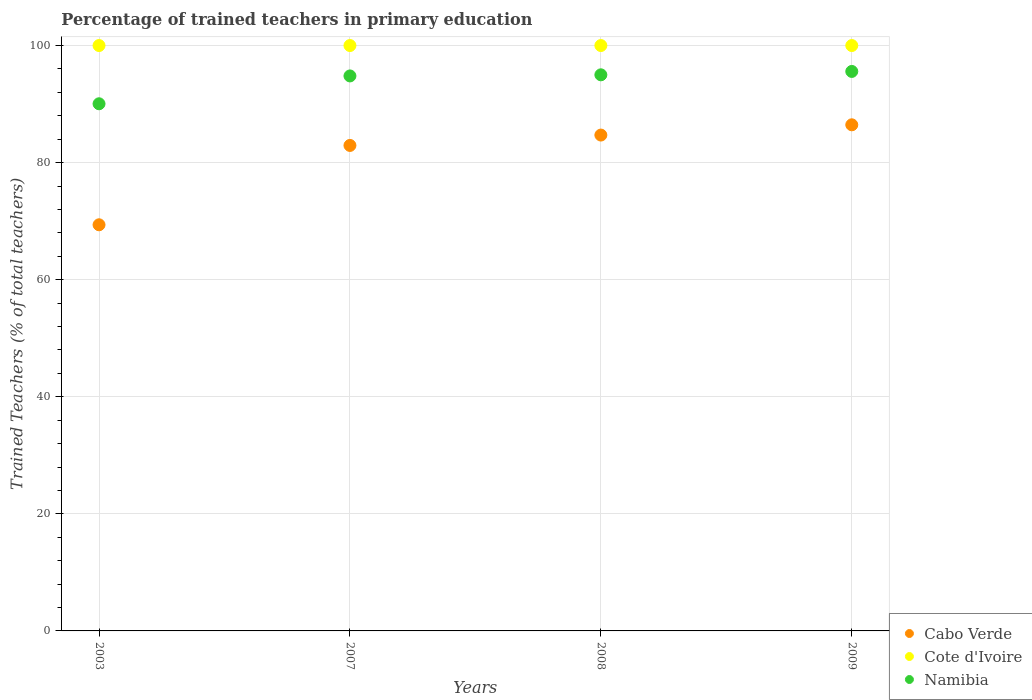What is the percentage of trained teachers in Namibia in 2009?
Ensure brevity in your answer.  95.58. Across all years, what is the maximum percentage of trained teachers in Namibia?
Make the answer very short. 95.58. Across all years, what is the minimum percentage of trained teachers in Cabo Verde?
Offer a very short reply. 69.38. In which year was the percentage of trained teachers in Cote d'Ivoire maximum?
Keep it short and to the point. 2003. In which year was the percentage of trained teachers in Cote d'Ivoire minimum?
Make the answer very short. 2003. What is the total percentage of trained teachers in Namibia in the graph?
Your answer should be compact. 375.43. What is the difference between the percentage of trained teachers in Cote d'Ivoire in 2008 and that in 2009?
Offer a terse response. 0. What is the difference between the percentage of trained teachers in Cabo Verde in 2008 and the percentage of trained teachers in Namibia in 2007?
Your answer should be compact. -10.1. In the year 2003, what is the difference between the percentage of trained teachers in Namibia and percentage of trained teachers in Cabo Verde?
Keep it short and to the point. 20.67. In how many years, is the percentage of trained teachers in Cabo Verde greater than 48 %?
Keep it short and to the point. 4. What is the ratio of the percentage of trained teachers in Cabo Verde in 2007 to that in 2008?
Offer a very short reply. 0.98. What is the difference between the highest and the second highest percentage of trained teachers in Cabo Verde?
Ensure brevity in your answer.  1.75. In how many years, is the percentage of trained teachers in Namibia greater than the average percentage of trained teachers in Namibia taken over all years?
Your answer should be very brief. 3. Is the percentage of trained teachers in Cote d'Ivoire strictly greater than the percentage of trained teachers in Cabo Verde over the years?
Keep it short and to the point. Yes. How many years are there in the graph?
Your answer should be very brief. 4. Does the graph contain any zero values?
Ensure brevity in your answer.  No. How are the legend labels stacked?
Your answer should be compact. Vertical. What is the title of the graph?
Offer a terse response. Percentage of trained teachers in primary education. Does "Other small states" appear as one of the legend labels in the graph?
Offer a terse response. No. What is the label or title of the X-axis?
Offer a very short reply. Years. What is the label or title of the Y-axis?
Your response must be concise. Trained Teachers (% of total teachers). What is the Trained Teachers (% of total teachers) in Cabo Verde in 2003?
Your answer should be compact. 69.38. What is the Trained Teachers (% of total teachers) in Cote d'Ivoire in 2003?
Ensure brevity in your answer.  100. What is the Trained Teachers (% of total teachers) in Namibia in 2003?
Your answer should be very brief. 90.05. What is the Trained Teachers (% of total teachers) of Cabo Verde in 2007?
Give a very brief answer. 82.93. What is the Trained Teachers (% of total teachers) of Cote d'Ivoire in 2007?
Provide a succinct answer. 100. What is the Trained Teachers (% of total teachers) in Namibia in 2007?
Your answer should be compact. 94.81. What is the Trained Teachers (% of total teachers) of Cabo Verde in 2008?
Offer a terse response. 84.71. What is the Trained Teachers (% of total teachers) in Namibia in 2008?
Give a very brief answer. 95. What is the Trained Teachers (% of total teachers) of Cabo Verde in 2009?
Ensure brevity in your answer.  86.46. What is the Trained Teachers (% of total teachers) in Namibia in 2009?
Offer a terse response. 95.58. Across all years, what is the maximum Trained Teachers (% of total teachers) of Cabo Verde?
Offer a very short reply. 86.46. Across all years, what is the maximum Trained Teachers (% of total teachers) of Namibia?
Make the answer very short. 95.58. Across all years, what is the minimum Trained Teachers (% of total teachers) of Cabo Verde?
Provide a succinct answer. 69.38. Across all years, what is the minimum Trained Teachers (% of total teachers) in Namibia?
Provide a short and direct response. 90.05. What is the total Trained Teachers (% of total teachers) of Cabo Verde in the graph?
Your response must be concise. 323.48. What is the total Trained Teachers (% of total teachers) in Cote d'Ivoire in the graph?
Make the answer very short. 400. What is the total Trained Teachers (% of total teachers) in Namibia in the graph?
Give a very brief answer. 375.43. What is the difference between the Trained Teachers (% of total teachers) in Cabo Verde in 2003 and that in 2007?
Make the answer very short. -13.55. What is the difference between the Trained Teachers (% of total teachers) of Namibia in 2003 and that in 2007?
Make the answer very short. -4.76. What is the difference between the Trained Teachers (% of total teachers) of Cabo Verde in 2003 and that in 2008?
Your answer should be very brief. -15.33. What is the difference between the Trained Teachers (% of total teachers) of Cote d'Ivoire in 2003 and that in 2008?
Your response must be concise. 0. What is the difference between the Trained Teachers (% of total teachers) in Namibia in 2003 and that in 2008?
Your answer should be compact. -4.95. What is the difference between the Trained Teachers (% of total teachers) in Cabo Verde in 2003 and that in 2009?
Keep it short and to the point. -17.08. What is the difference between the Trained Teachers (% of total teachers) in Cote d'Ivoire in 2003 and that in 2009?
Offer a very short reply. 0. What is the difference between the Trained Teachers (% of total teachers) of Namibia in 2003 and that in 2009?
Offer a terse response. -5.52. What is the difference between the Trained Teachers (% of total teachers) of Cabo Verde in 2007 and that in 2008?
Make the answer very short. -1.77. What is the difference between the Trained Teachers (% of total teachers) in Cote d'Ivoire in 2007 and that in 2008?
Give a very brief answer. 0. What is the difference between the Trained Teachers (% of total teachers) in Namibia in 2007 and that in 2008?
Give a very brief answer. -0.19. What is the difference between the Trained Teachers (% of total teachers) in Cabo Verde in 2007 and that in 2009?
Give a very brief answer. -3.52. What is the difference between the Trained Teachers (% of total teachers) of Namibia in 2007 and that in 2009?
Keep it short and to the point. -0.77. What is the difference between the Trained Teachers (% of total teachers) in Cabo Verde in 2008 and that in 2009?
Provide a short and direct response. -1.75. What is the difference between the Trained Teachers (% of total teachers) in Namibia in 2008 and that in 2009?
Keep it short and to the point. -0.58. What is the difference between the Trained Teachers (% of total teachers) in Cabo Verde in 2003 and the Trained Teachers (% of total teachers) in Cote d'Ivoire in 2007?
Offer a very short reply. -30.62. What is the difference between the Trained Teachers (% of total teachers) in Cabo Verde in 2003 and the Trained Teachers (% of total teachers) in Namibia in 2007?
Keep it short and to the point. -25.43. What is the difference between the Trained Teachers (% of total teachers) in Cote d'Ivoire in 2003 and the Trained Teachers (% of total teachers) in Namibia in 2007?
Provide a succinct answer. 5.19. What is the difference between the Trained Teachers (% of total teachers) of Cabo Verde in 2003 and the Trained Teachers (% of total teachers) of Cote d'Ivoire in 2008?
Provide a short and direct response. -30.62. What is the difference between the Trained Teachers (% of total teachers) of Cabo Verde in 2003 and the Trained Teachers (% of total teachers) of Namibia in 2008?
Offer a terse response. -25.62. What is the difference between the Trained Teachers (% of total teachers) of Cote d'Ivoire in 2003 and the Trained Teachers (% of total teachers) of Namibia in 2008?
Provide a short and direct response. 5. What is the difference between the Trained Teachers (% of total teachers) in Cabo Verde in 2003 and the Trained Teachers (% of total teachers) in Cote d'Ivoire in 2009?
Offer a very short reply. -30.62. What is the difference between the Trained Teachers (% of total teachers) in Cabo Verde in 2003 and the Trained Teachers (% of total teachers) in Namibia in 2009?
Give a very brief answer. -26.2. What is the difference between the Trained Teachers (% of total teachers) in Cote d'Ivoire in 2003 and the Trained Teachers (% of total teachers) in Namibia in 2009?
Offer a terse response. 4.42. What is the difference between the Trained Teachers (% of total teachers) of Cabo Verde in 2007 and the Trained Teachers (% of total teachers) of Cote d'Ivoire in 2008?
Provide a succinct answer. -17.07. What is the difference between the Trained Teachers (% of total teachers) in Cabo Verde in 2007 and the Trained Teachers (% of total teachers) in Namibia in 2008?
Your answer should be very brief. -12.06. What is the difference between the Trained Teachers (% of total teachers) of Cote d'Ivoire in 2007 and the Trained Teachers (% of total teachers) of Namibia in 2008?
Your answer should be compact. 5. What is the difference between the Trained Teachers (% of total teachers) of Cabo Verde in 2007 and the Trained Teachers (% of total teachers) of Cote d'Ivoire in 2009?
Your response must be concise. -17.07. What is the difference between the Trained Teachers (% of total teachers) of Cabo Verde in 2007 and the Trained Teachers (% of total teachers) of Namibia in 2009?
Keep it short and to the point. -12.64. What is the difference between the Trained Teachers (% of total teachers) of Cote d'Ivoire in 2007 and the Trained Teachers (% of total teachers) of Namibia in 2009?
Ensure brevity in your answer.  4.42. What is the difference between the Trained Teachers (% of total teachers) of Cabo Verde in 2008 and the Trained Teachers (% of total teachers) of Cote d'Ivoire in 2009?
Offer a terse response. -15.29. What is the difference between the Trained Teachers (% of total teachers) of Cabo Verde in 2008 and the Trained Teachers (% of total teachers) of Namibia in 2009?
Provide a short and direct response. -10.87. What is the difference between the Trained Teachers (% of total teachers) in Cote d'Ivoire in 2008 and the Trained Teachers (% of total teachers) in Namibia in 2009?
Provide a short and direct response. 4.42. What is the average Trained Teachers (% of total teachers) of Cabo Verde per year?
Offer a very short reply. 80.87. What is the average Trained Teachers (% of total teachers) in Cote d'Ivoire per year?
Give a very brief answer. 100. What is the average Trained Teachers (% of total teachers) of Namibia per year?
Give a very brief answer. 93.86. In the year 2003, what is the difference between the Trained Teachers (% of total teachers) in Cabo Verde and Trained Teachers (% of total teachers) in Cote d'Ivoire?
Your answer should be very brief. -30.62. In the year 2003, what is the difference between the Trained Teachers (% of total teachers) in Cabo Verde and Trained Teachers (% of total teachers) in Namibia?
Your answer should be compact. -20.67. In the year 2003, what is the difference between the Trained Teachers (% of total teachers) in Cote d'Ivoire and Trained Teachers (% of total teachers) in Namibia?
Your response must be concise. 9.95. In the year 2007, what is the difference between the Trained Teachers (% of total teachers) of Cabo Verde and Trained Teachers (% of total teachers) of Cote d'Ivoire?
Keep it short and to the point. -17.07. In the year 2007, what is the difference between the Trained Teachers (% of total teachers) in Cabo Verde and Trained Teachers (% of total teachers) in Namibia?
Make the answer very short. -11.87. In the year 2007, what is the difference between the Trained Teachers (% of total teachers) of Cote d'Ivoire and Trained Teachers (% of total teachers) of Namibia?
Your response must be concise. 5.19. In the year 2008, what is the difference between the Trained Teachers (% of total teachers) of Cabo Verde and Trained Teachers (% of total teachers) of Cote d'Ivoire?
Provide a short and direct response. -15.29. In the year 2008, what is the difference between the Trained Teachers (% of total teachers) in Cabo Verde and Trained Teachers (% of total teachers) in Namibia?
Your response must be concise. -10.29. In the year 2008, what is the difference between the Trained Teachers (% of total teachers) of Cote d'Ivoire and Trained Teachers (% of total teachers) of Namibia?
Your response must be concise. 5. In the year 2009, what is the difference between the Trained Teachers (% of total teachers) in Cabo Verde and Trained Teachers (% of total teachers) in Cote d'Ivoire?
Make the answer very short. -13.54. In the year 2009, what is the difference between the Trained Teachers (% of total teachers) in Cabo Verde and Trained Teachers (% of total teachers) in Namibia?
Your response must be concise. -9.12. In the year 2009, what is the difference between the Trained Teachers (% of total teachers) in Cote d'Ivoire and Trained Teachers (% of total teachers) in Namibia?
Your answer should be very brief. 4.42. What is the ratio of the Trained Teachers (% of total teachers) of Cabo Verde in 2003 to that in 2007?
Make the answer very short. 0.84. What is the ratio of the Trained Teachers (% of total teachers) of Namibia in 2003 to that in 2007?
Make the answer very short. 0.95. What is the ratio of the Trained Teachers (% of total teachers) of Cabo Verde in 2003 to that in 2008?
Your answer should be very brief. 0.82. What is the ratio of the Trained Teachers (% of total teachers) in Cote d'Ivoire in 2003 to that in 2008?
Ensure brevity in your answer.  1. What is the ratio of the Trained Teachers (% of total teachers) in Namibia in 2003 to that in 2008?
Provide a succinct answer. 0.95. What is the ratio of the Trained Teachers (% of total teachers) in Cabo Verde in 2003 to that in 2009?
Make the answer very short. 0.8. What is the ratio of the Trained Teachers (% of total teachers) of Namibia in 2003 to that in 2009?
Offer a terse response. 0.94. What is the ratio of the Trained Teachers (% of total teachers) of Cabo Verde in 2007 to that in 2008?
Provide a short and direct response. 0.98. What is the ratio of the Trained Teachers (% of total teachers) of Cote d'Ivoire in 2007 to that in 2008?
Ensure brevity in your answer.  1. What is the ratio of the Trained Teachers (% of total teachers) of Namibia in 2007 to that in 2008?
Make the answer very short. 1. What is the ratio of the Trained Teachers (% of total teachers) in Cabo Verde in 2007 to that in 2009?
Provide a succinct answer. 0.96. What is the ratio of the Trained Teachers (% of total teachers) in Cote d'Ivoire in 2007 to that in 2009?
Offer a terse response. 1. What is the ratio of the Trained Teachers (% of total teachers) of Namibia in 2007 to that in 2009?
Provide a succinct answer. 0.99. What is the ratio of the Trained Teachers (% of total teachers) in Cabo Verde in 2008 to that in 2009?
Give a very brief answer. 0.98. What is the ratio of the Trained Teachers (% of total teachers) of Namibia in 2008 to that in 2009?
Offer a terse response. 0.99. What is the difference between the highest and the second highest Trained Teachers (% of total teachers) in Cabo Verde?
Your answer should be very brief. 1.75. What is the difference between the highest and the second highest Trained Teachers (% of total teachers) of Namibia?
Keep it short and to the point. 0.58. What is the difference between the highest and the lowest Trained Teachers (% of total teachers) of Cabo Verde?
Keep it short and to the point. 17.08. What is the difference between the highest and the lowest Trained Teachers (% of total teachers) of Cote d'Ivoire?
Provide a short and direct response. 0. What is the difference between the highest and the lowest Trained Teachers (% of total teachers) in Namibia?
Offer a very short reply. 5.52. 